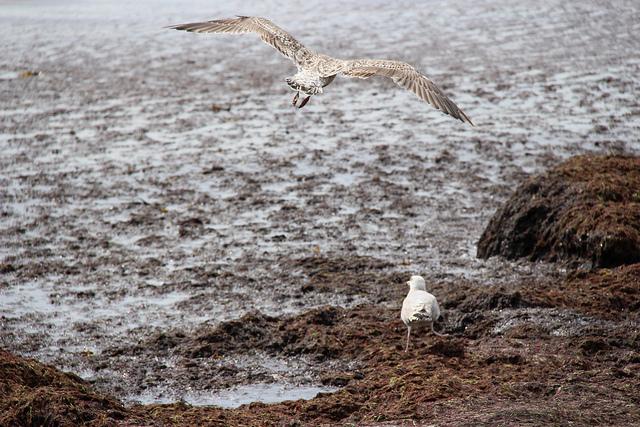Is the bird flying?
Write a very short answer. Yes. Are the birds alive?
Concise answer only. Yes. Is the shore visible in this picture?
Short answer required. Yes. Are there only 2 birds?
Short answer required. Yes. Where is the smaller bird?
Short answer required. Ground. Are these eagles?
Concise answer only. No. What color are these birds?
Keep it brief. White. How does this bird's wingspan compare to that of a typical adult bald eagle?
Answer briefly. Smaller. How many teddy bears are there?
Write a very short answer. 0. 